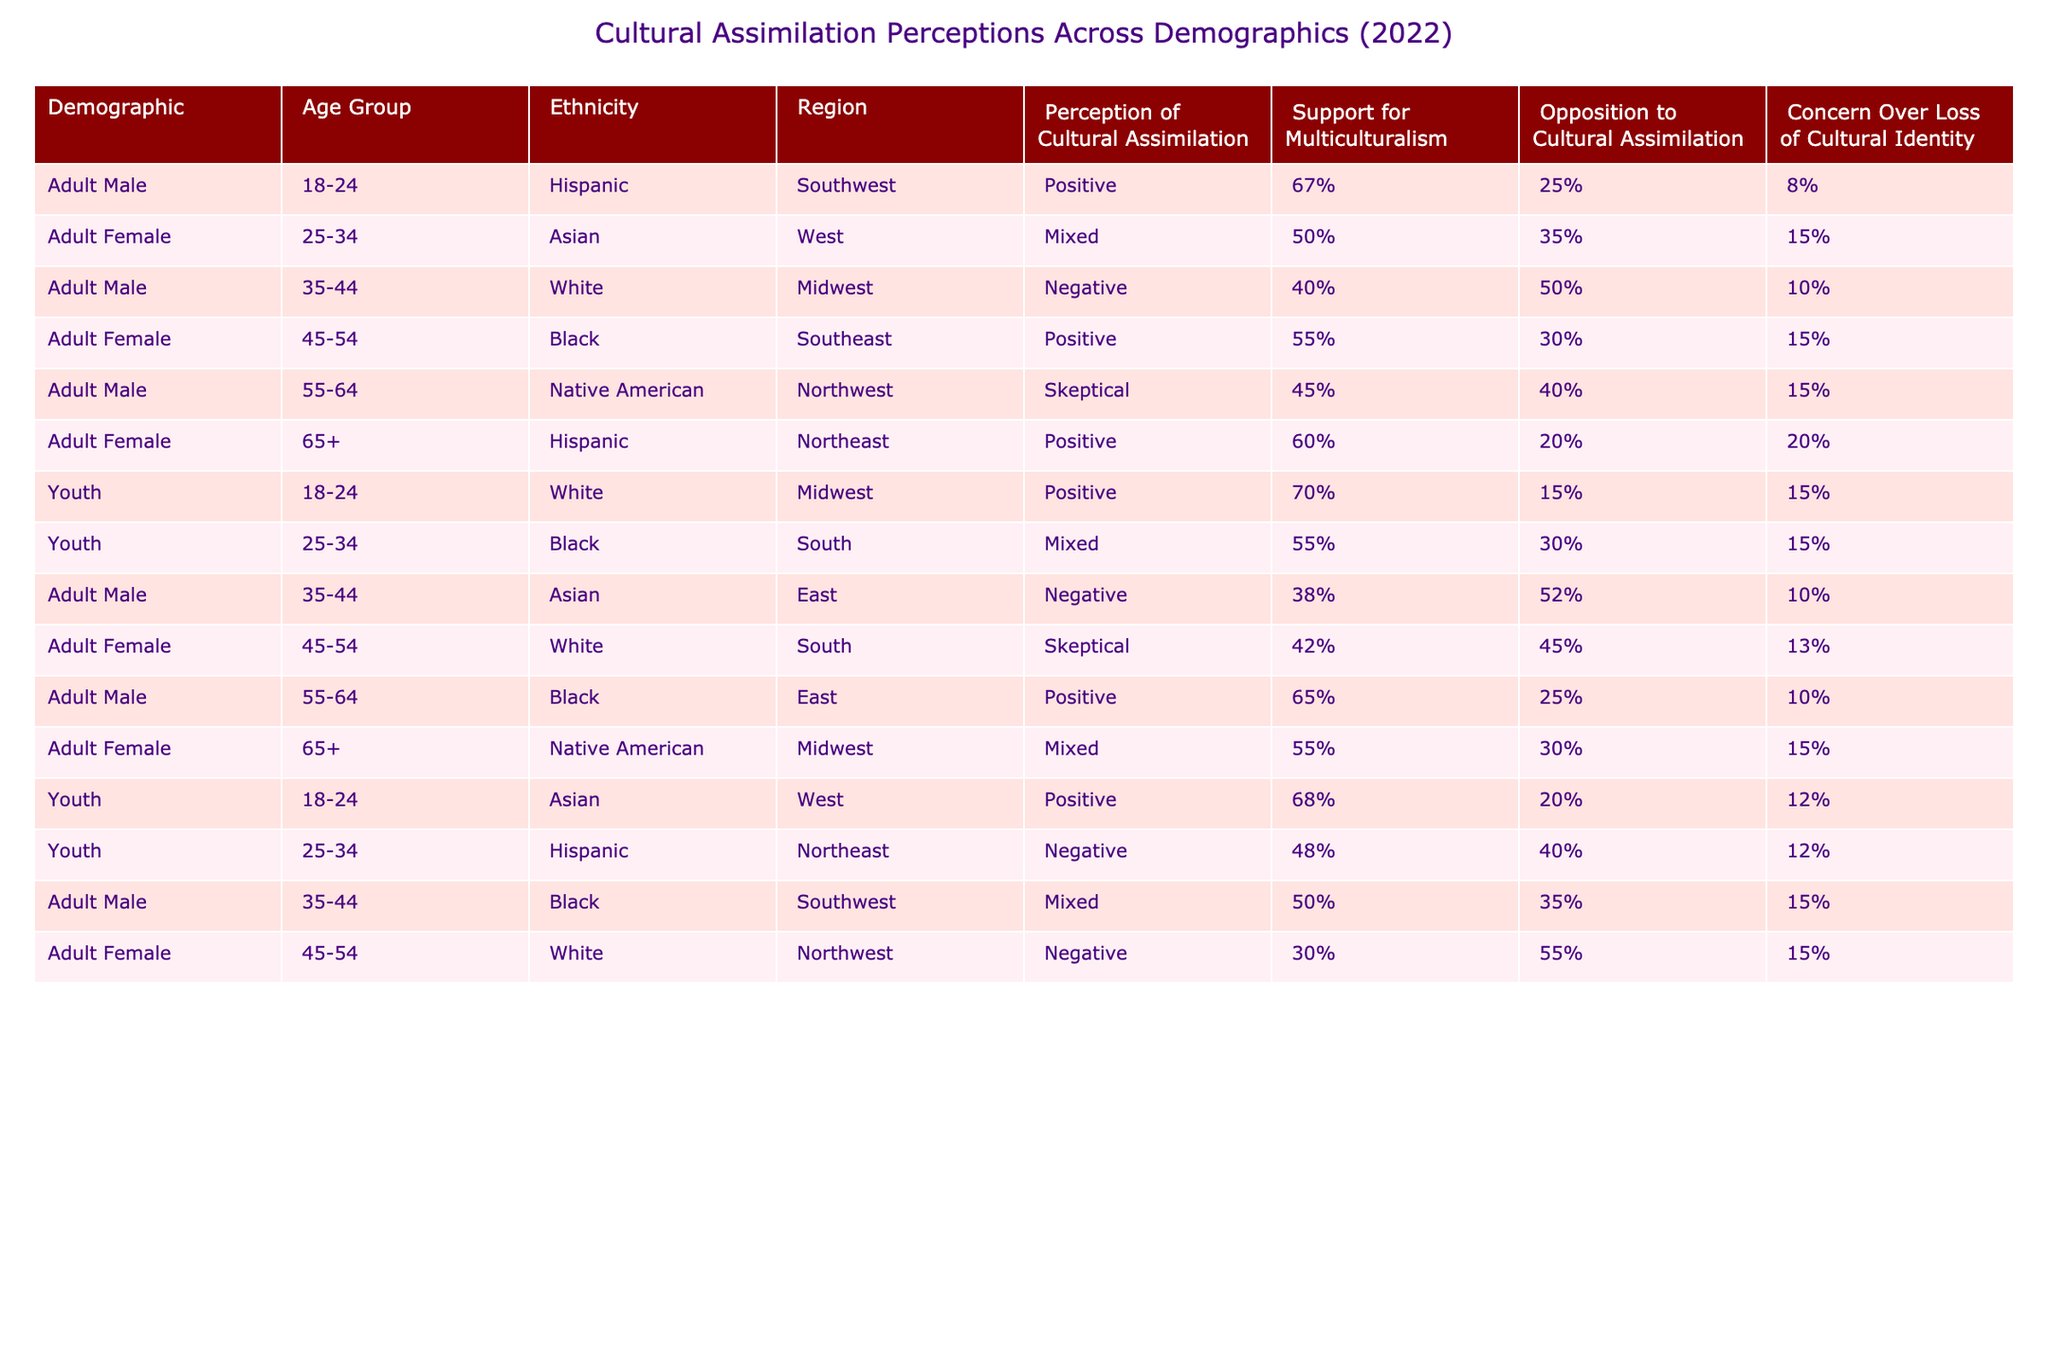What percentage of Youth aged 18-24 in the Midwest have a positive perception of cultural assimilation? The table shows one entry for Youth aged 18-24 in the Midwest, which states a positive perception of cultural assimilation at 70%.
Answer: 70% Which demographic group has the highest support for multiculturalism? Checking the table, Adult Male aged 18-24 (Hispanic) shows the highest support for multiculturalism at 67%.
Answer: 67% What is the average opposition to cultural assimilation among Adult Females across all age groups? Adding the percentages of opposition to cultural assimilation for Adult Females: 15% (Asian) + 15% (Black) + 10% (White) + 15% (Native American) + 13% (White) = 68%. Dividing by the 5 data points gives an average of 68% / 5 = 13.6%.
Answer: 13.6% Is there any demographic that shows a mixed perception of cultural assimilation? Referring to the table, Adult Females aged 25-34 (Asian), aged 45-54 (White), and Youth aged 25-34 (Black) all have a mixed perception, confirming that yes, there are demographics with mixed perceptions.
Answer: Yes How does the perception of cultural assimilation differ between Hispanic and Black Adult Females? Adult Females aged 45-54 (Black) have a positive perception at 55%, while older Hispanic Adult Females aged 65+ exhibit a positive perception at 60%. The difference between them is that the Hispanic demographic has a slightly higher positive perception by 5%.
Answer: 5% What is the total percentage of individuals who are skeptical about cultural assimilation among the identified demographics? The table shows two demographics classified as skeptical: Adult Male aged 55-64 (45%) and Adult Female aged 45-54 (42%). Adding these gives a total of 45% + 42% = 87% for all demographics.
Answer: 87% For Youth aged 25-34 in the South, is their support for multiculturalism higher than their opposition? The table shows that Youth aged 25-34 (Black) have a support of 30% and opposition of 15%. As 30% > 15%, this indicates that their support is indeed higher.
Answer: Yes What is the significant trend observed in the perception of cultural assimilation among different age groups? The table suggests that younger demographics, particularly those aged 18-24, tend to express more positive perceptions compared to older age groups where skepticism or negative perceptions occur more frequently.
Answer: Younger demographics are more positive 